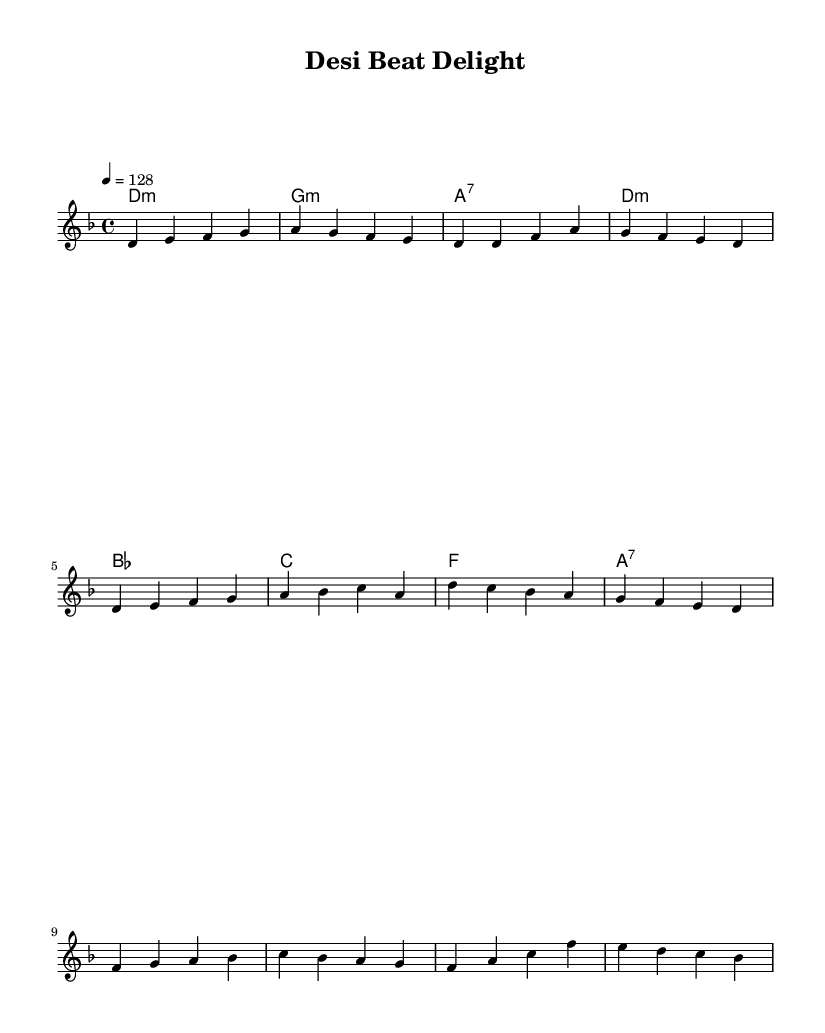What is the key signature of this music? The key signature is D minor, which has one flat (B flat). The key is indicated at the beginning of the score after the clef.
Answer: D minor What is the time signature of this music? The time signature is 4/4, which means there are four beats in each measure. This is specified at the beginning of the score before the notes.
Answer: 4/4 What is the tempo of this music? The tempo is set at 128 beats per minute, which is indicated at the beginning of the score with the term “4 = 128.” This specifies how fast the music should be played.
Answer: 128 How many measures are in the main theme? The main theme consists of 8 measures, each separated by vertical lines on the staff. Counting each of them confirms this total.
Answer: 8 Which chord is used at the end of the harmony section? The last chord in the harmony section is A7, which is the final chord listed in the chord progression. This can be identified at the end of the chord line.
Answer: A7 Which note starts the bridge section? The bridge section starts with the note F, as indicated at the beginning of that part on the melody line. This is the first note in the new thematic section.
Answer: F What is the last note played in the melody? The last note in the melody is B flat, which is the final note in the last measure of the main theme and is located at the end of the melody line.
Answer: B flat 